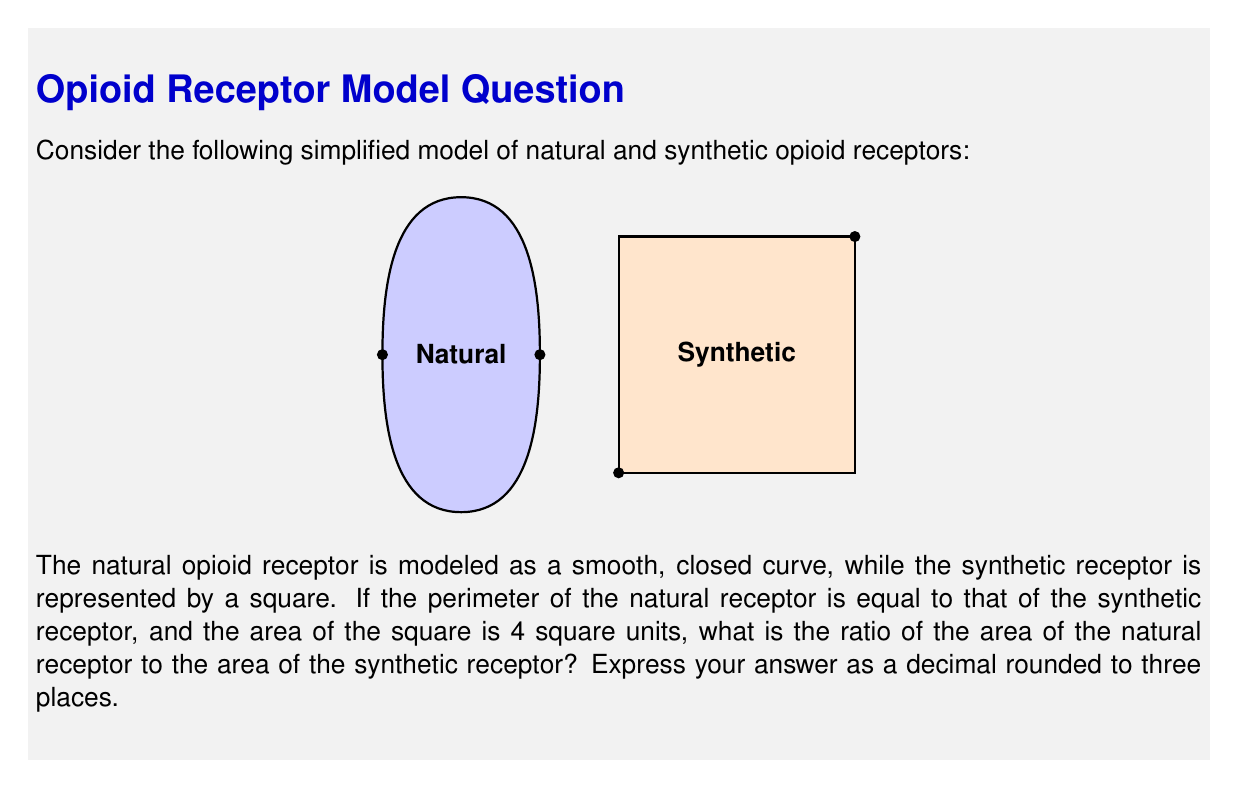Help me with this question. Let's approach this step-by-step:

1) For the synthetic receptor (square):
   - Area = 4 square units
   - Side length = $\sqrt{4} = 2$ units
   - Perimeter = $4 * 2 = 8$ units

2) For the natural receptor:
   - We know its perimeter is equal to the square's, so it's also 8 units

3) The natural receptor shape resembles a circle. While it's not a perfect circle, we can use the isoperimetric inequality, which states that among all closed curves with a given perimeter, the circle encloses the maximum area.

4) For a circle with perimeter 8:
   - Perimeter = $2\pi r = 8$
   - Radius $r = \frac{8}{2\pi} = \frac{4}{\pi}$
   - Maximum possible area = $\pi r^2 = \pi (\frac{4}{\pi})^2 = \frac{16}{\pi}$

5) The actual area of the natural receptor will be less than this maximum. Let's estimate it's about 90% of the maximum circular area:
   
   Estimated area of natural receptor = $0.9 * \frac{16}{\pi} = \frac{14.4}{\pi}$

6) Ratio of areas:
   $\frac{\text{Area of natural receptor}}{\text{Area of synthetic receptor}} = \frac{14.4/\pi}{4} = \frac{3.6}{\pi} \approx 1.146$

This ratio suggests that despite having the same perimeter, the natural receptor has a slightly larger area than the synthetic one, potentially allowing for more flexible binding.
Answer: 1.146 